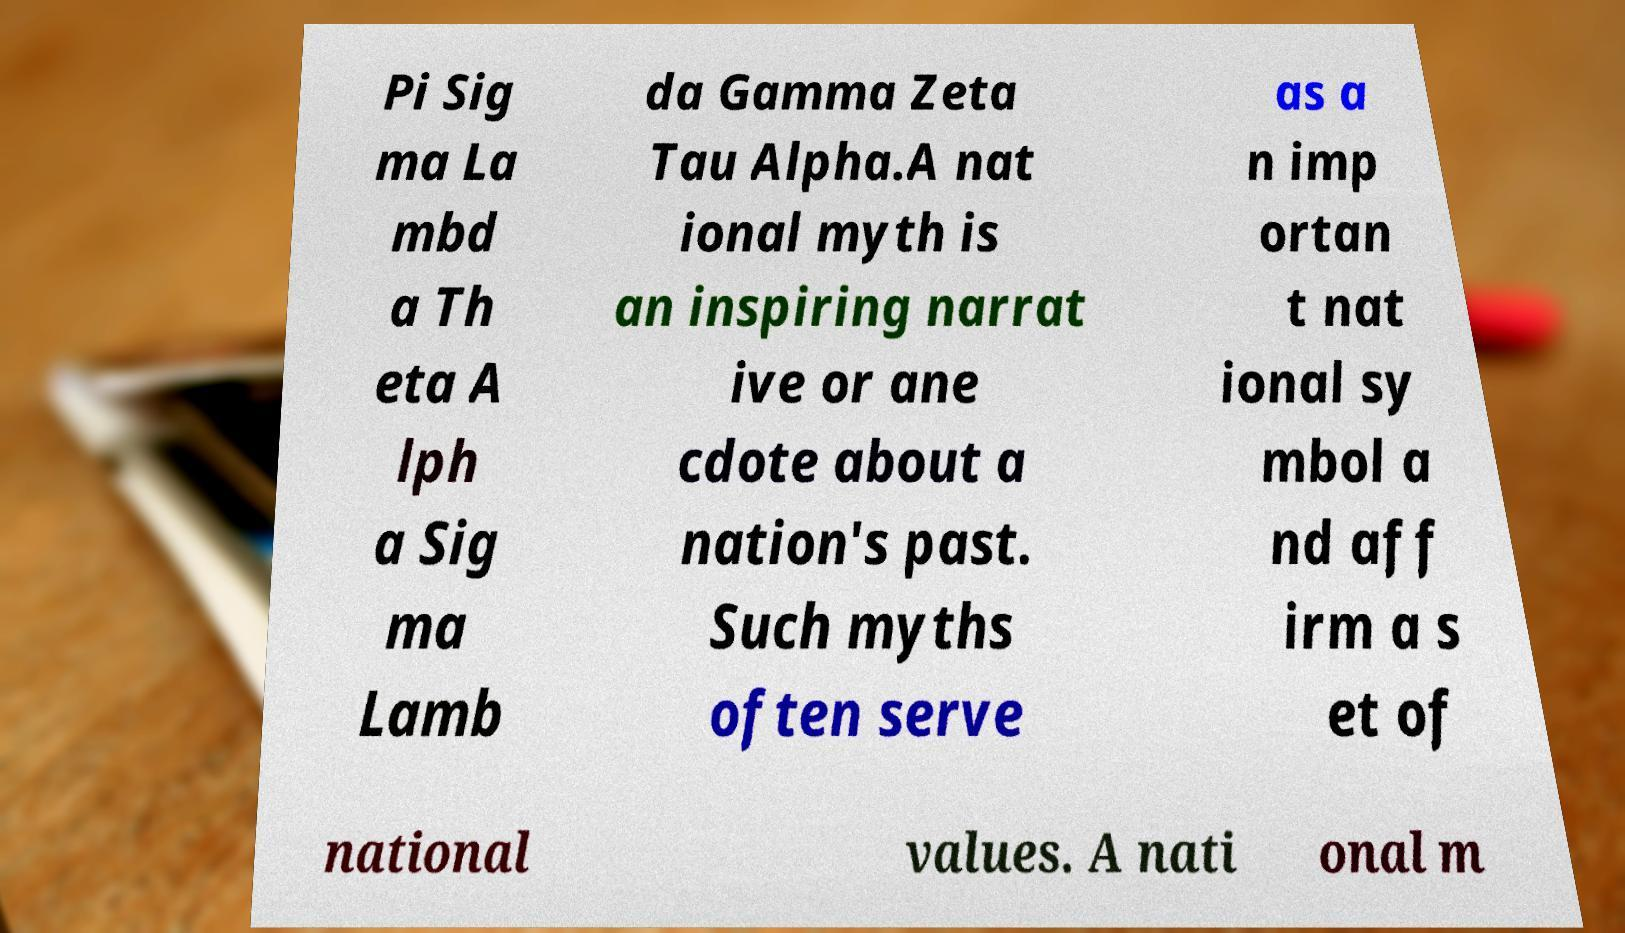Can you accurately transcribe the text from the provided image for me? Pi Sig ma La mbd a Th eta A lph a Sig ma Lamb da Gamma Zeta Tau Alpha.A nat ional myth is an inspiring narrat ive or ane cdote about a nation's past. Such myths often serve as a n imp ortan t nat ional sy mbol a nd aff irm a s et of national values. A nati onal m 